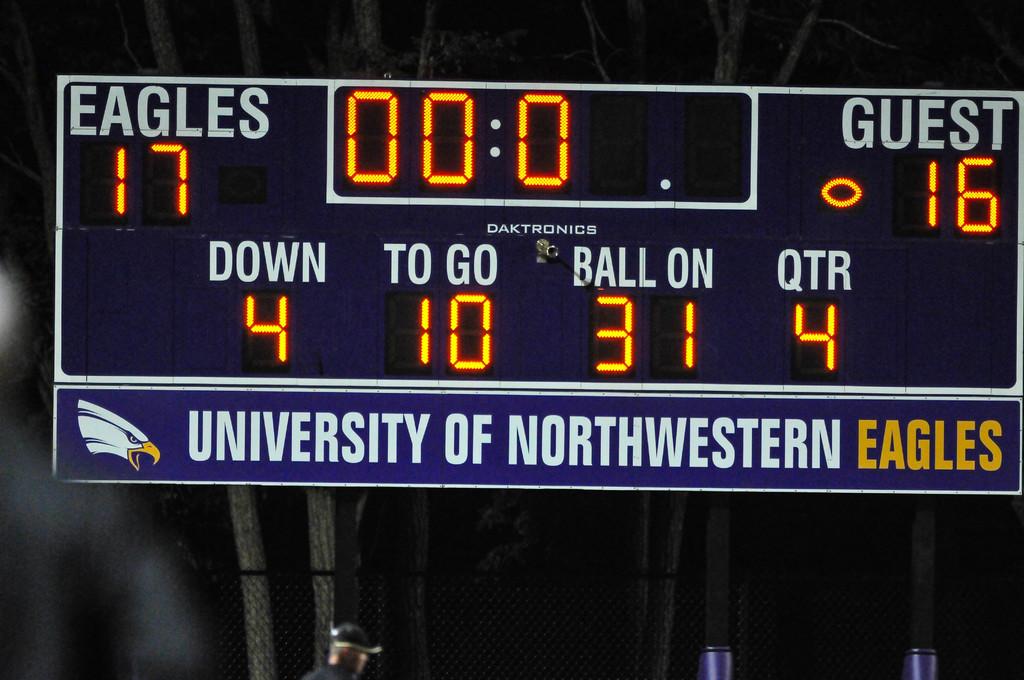Which school plays their home games here?
Your answer should be very brief. University of northwestern. Where was the game held?
Keep it short and to the point. University of northwestern. 